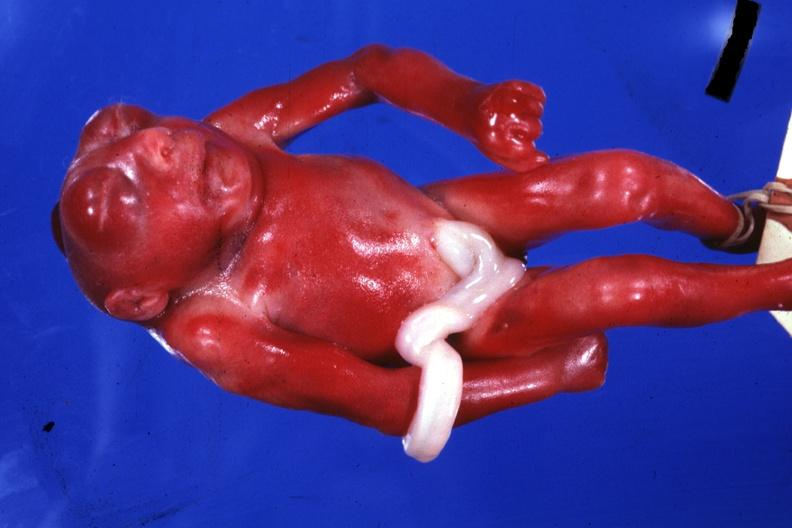what does this image show?
Answer the question using a single word or phrase. Whole body small fetus typical 